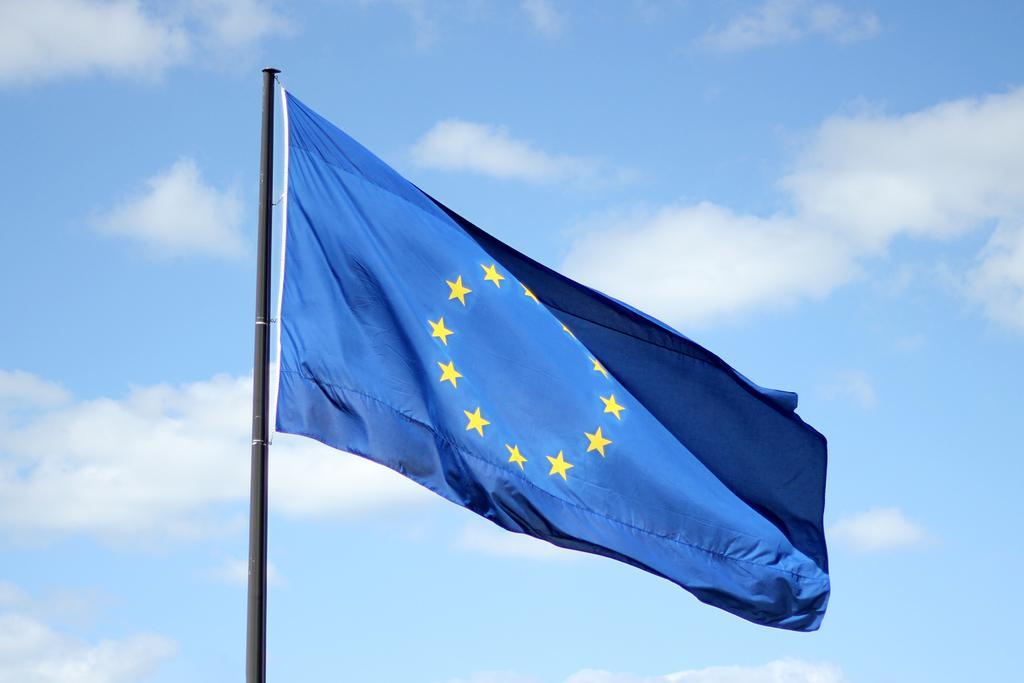Can you describe this image briefly? In this image we can see a blue color flag in the center. In the background there is sky with some clouds. 